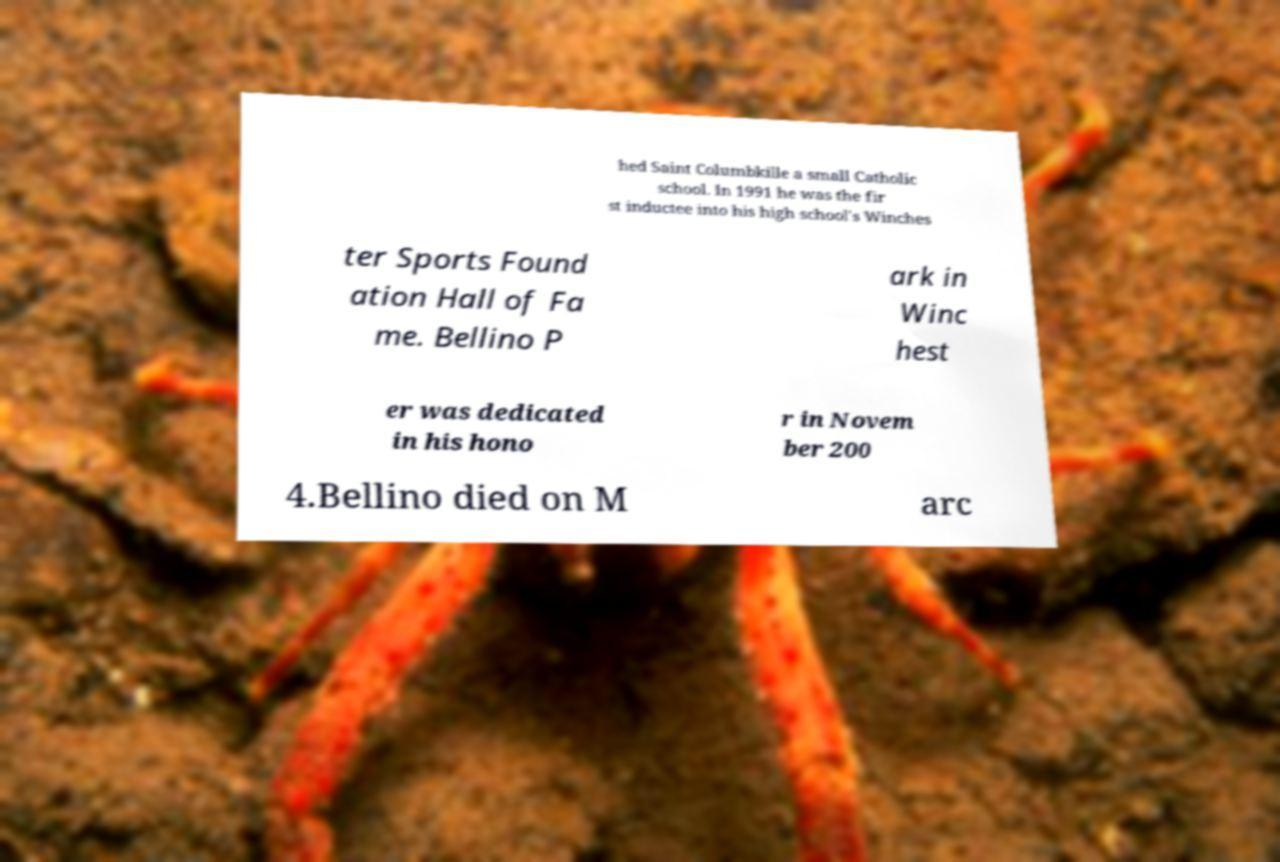Please read and relay the text visible in this image. What does it say? hed Saint Columbkille a small Catholic school. In 1991 he was the fir st inductee into his high school's Winches ter Sports Found ation Hall of Fa me. Bellino P ark in Winc hest er was dedicated in his hono r in Novem ber 200 4.Bellino died on M arc 